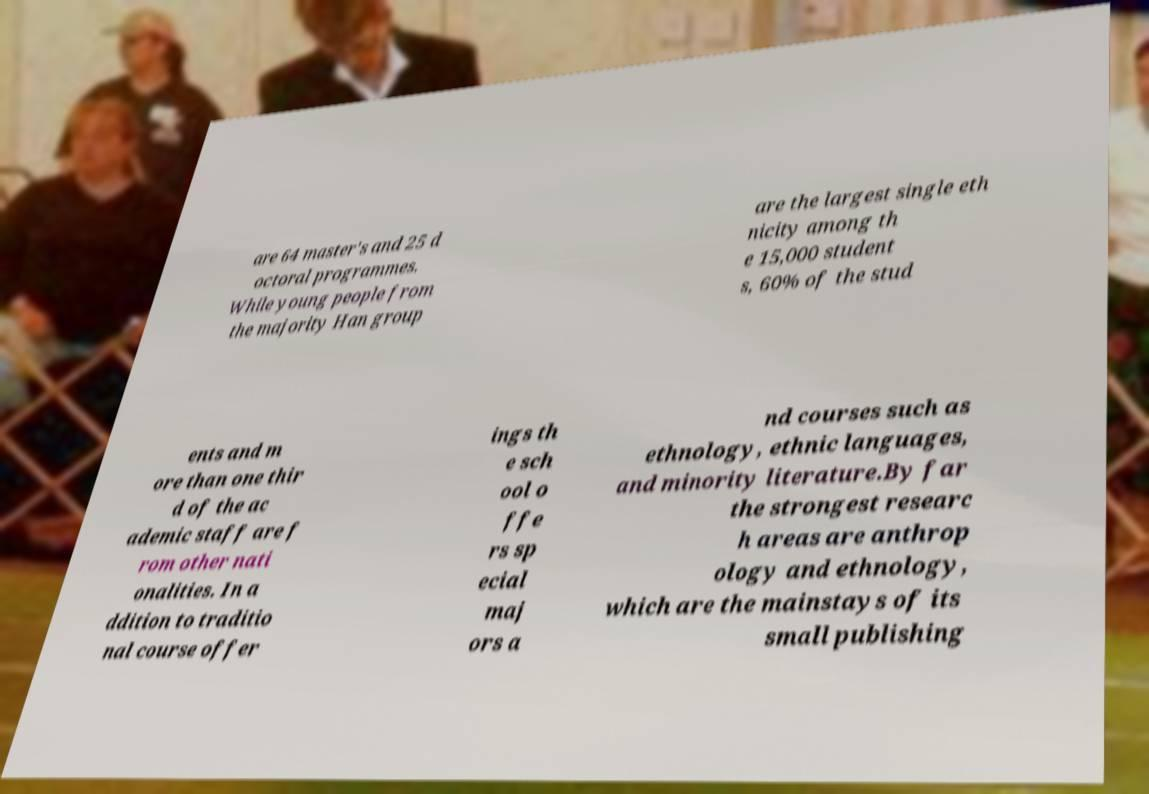Could you assist in decoding the text presented in this image and type it out clearly? are 64 master's and 25 d octoral programmes. While young people from the majority Han group are the largest single eth nicity among th e 15,000 student s, 60% of the stud ents and m ore than one thir d of the ac ademic staff are f rom other nati onalities. In a ddition to traditio nal course offer ings th e sch ool o ffe rs sp ecial maj ors a nd courses such as ethnology, ethnic languages, and minority literature.By far the strongest researc h areas are anthrop ology and ethnology, which are the mainstays of its small publishing 